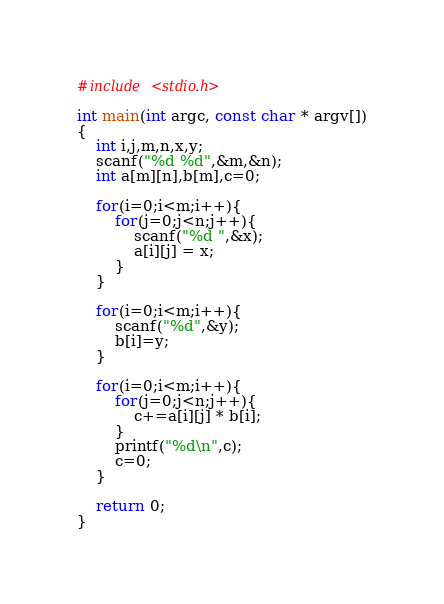<code> <loc_0><loc_0><loc_500><loc_500><_C_>#include <stdio.h>

int main(int argc, const char * argv[])
{
    int i,j,m,n,x,y;
    scanf("%d %d",&m,&n);
    int a[m][n],b[m],c=0;
    
    for(i=0;i<m;i++){
        for(j=0;j<n;j++){
            scanf("%d ",&x);
            a[i][j] = x;
        }
    }
    
    for(i=0;i<m;i++){
        scanf("%d",&y);
        b[i]=y;
    }
    
    for(i=0;i<m;i++){
        for(j=0;j<n;j++){
            c+=a[i][j] * b[i];
        }
        printf("%d\n",c);
        c=0;
    }
    
    return 0;
}</code> 